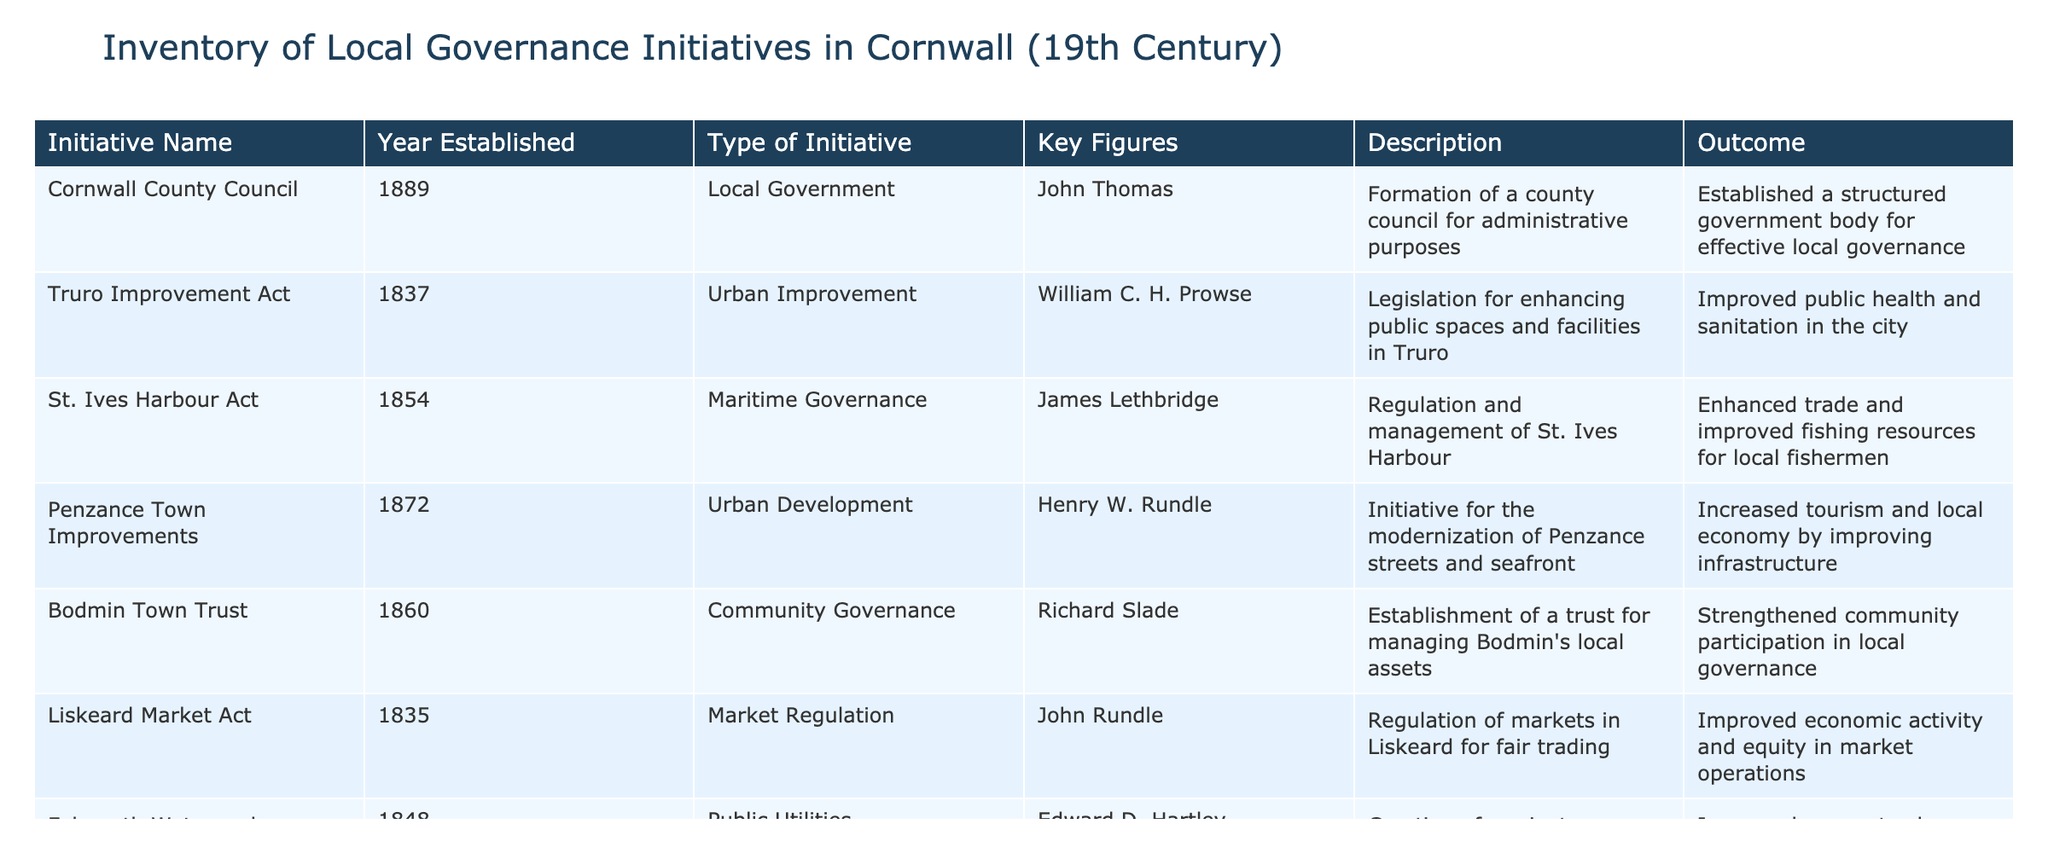What year was the Cornwall County Council established? The table shows that the Cornwall County Council was established in 1889. This information can be directly retrieved from the "Year Established" column corresponding to the "Cornwall County Council" initiative.
Answer: 1889 Which initiative focused on urban improvement in Truro? The "Truro Improvement Act" initiative aimed at urban improvement in Truro, as indicated in the table's "Initiative Name" and "Type of Initiative" columns.
Answer: Truro Improvement Act How many initiatives specifically aimed at education reform were established? The table lists one initiative, the "Cornwall Education Act", which falls under the "Education Reform" category. Therefore, there is a total of one education reform initiative in the table.
Answer: 1 Did any initiative established before 1850 relate to public utilities? Looking at the "Year Established" column, the "Falmouth Waterworks Company" was created in 1848, which is before 1850 and is classified as a public utilities initiative. Therefore, the answer is yes.
Answer: Yes Which type of initiative was the most common among the initiatives listed? Analyzing the "Type of Initiative" column, we see that there are four urban-related initiatives (Urban Improvement, Urban Development, Community Governance, and Market Regulation) while other categories are less frequent. Hence, urban-related initiatives are the most common type.
Answer: Urban-related initiatives What was the outcome of the Penzance Town Improvements initiative? The table states that the outcome of the Penzance Town Improvements was an increase in tourism and the local economy due to improved infrastructure, which captures the essence of its impact on the community.
Answer: Increased tourism and local economy What years did maritime governance initiatives span? The "St. Ives Harbour Act" (1854) is the only maritime governance initiative listed. Therefore, the span of maritime governance initiatives is limited to just that year.
Answer: 1854 How many initiatives were established between 1835 and 1870? By counting the initiatives established in the years of interest, we find five initiatives: Liskeard Market Act (1835), Truro Improvement Act (1837), Falmouth Waterworks Company (1848), Bodmin Town Trust (1860), and Cornwall Education Act (1870). Thus, there are five initiatives within this timeline.
Answer: 5 Which key figure was associated with the Cornwall Education Act? In the table, the key figure for the Cornwall Education Act is listed as Thomas W. Hammersley. This can be confirmed by looking at the corresponding entry under "Key Figures" for that initiative.
Answer: Thomas W. Hammersley 